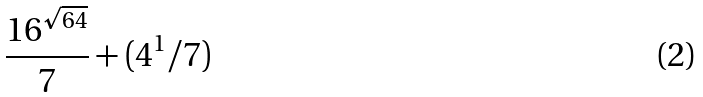Convert formula to latex. <formula><loc_0><loc_0><loc_500><loc_500>\frac { 1 6 ^ { \sqrt { 6 4 } } } { 7 } + ( 4 ^ { 1 } / 7 )</formula> 